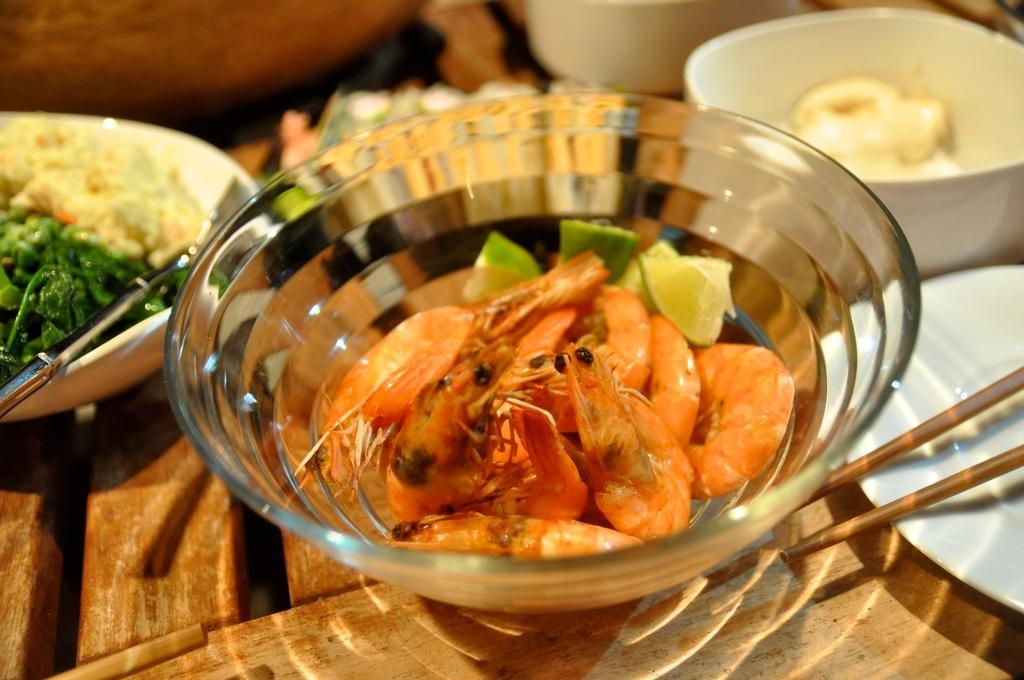What is in the bowls that are visible in the image? There is a group of bowls containing food in the image. What utensils are present in the image? Spoons are visible in the image, and chopsticks are present on the right side of the image. What type of lamp is present in the image? There is no lamp present in the image. What trick is being performed with the food in the image? There is no trick being performed in the image; it simply shows bowls of food with utensils. 